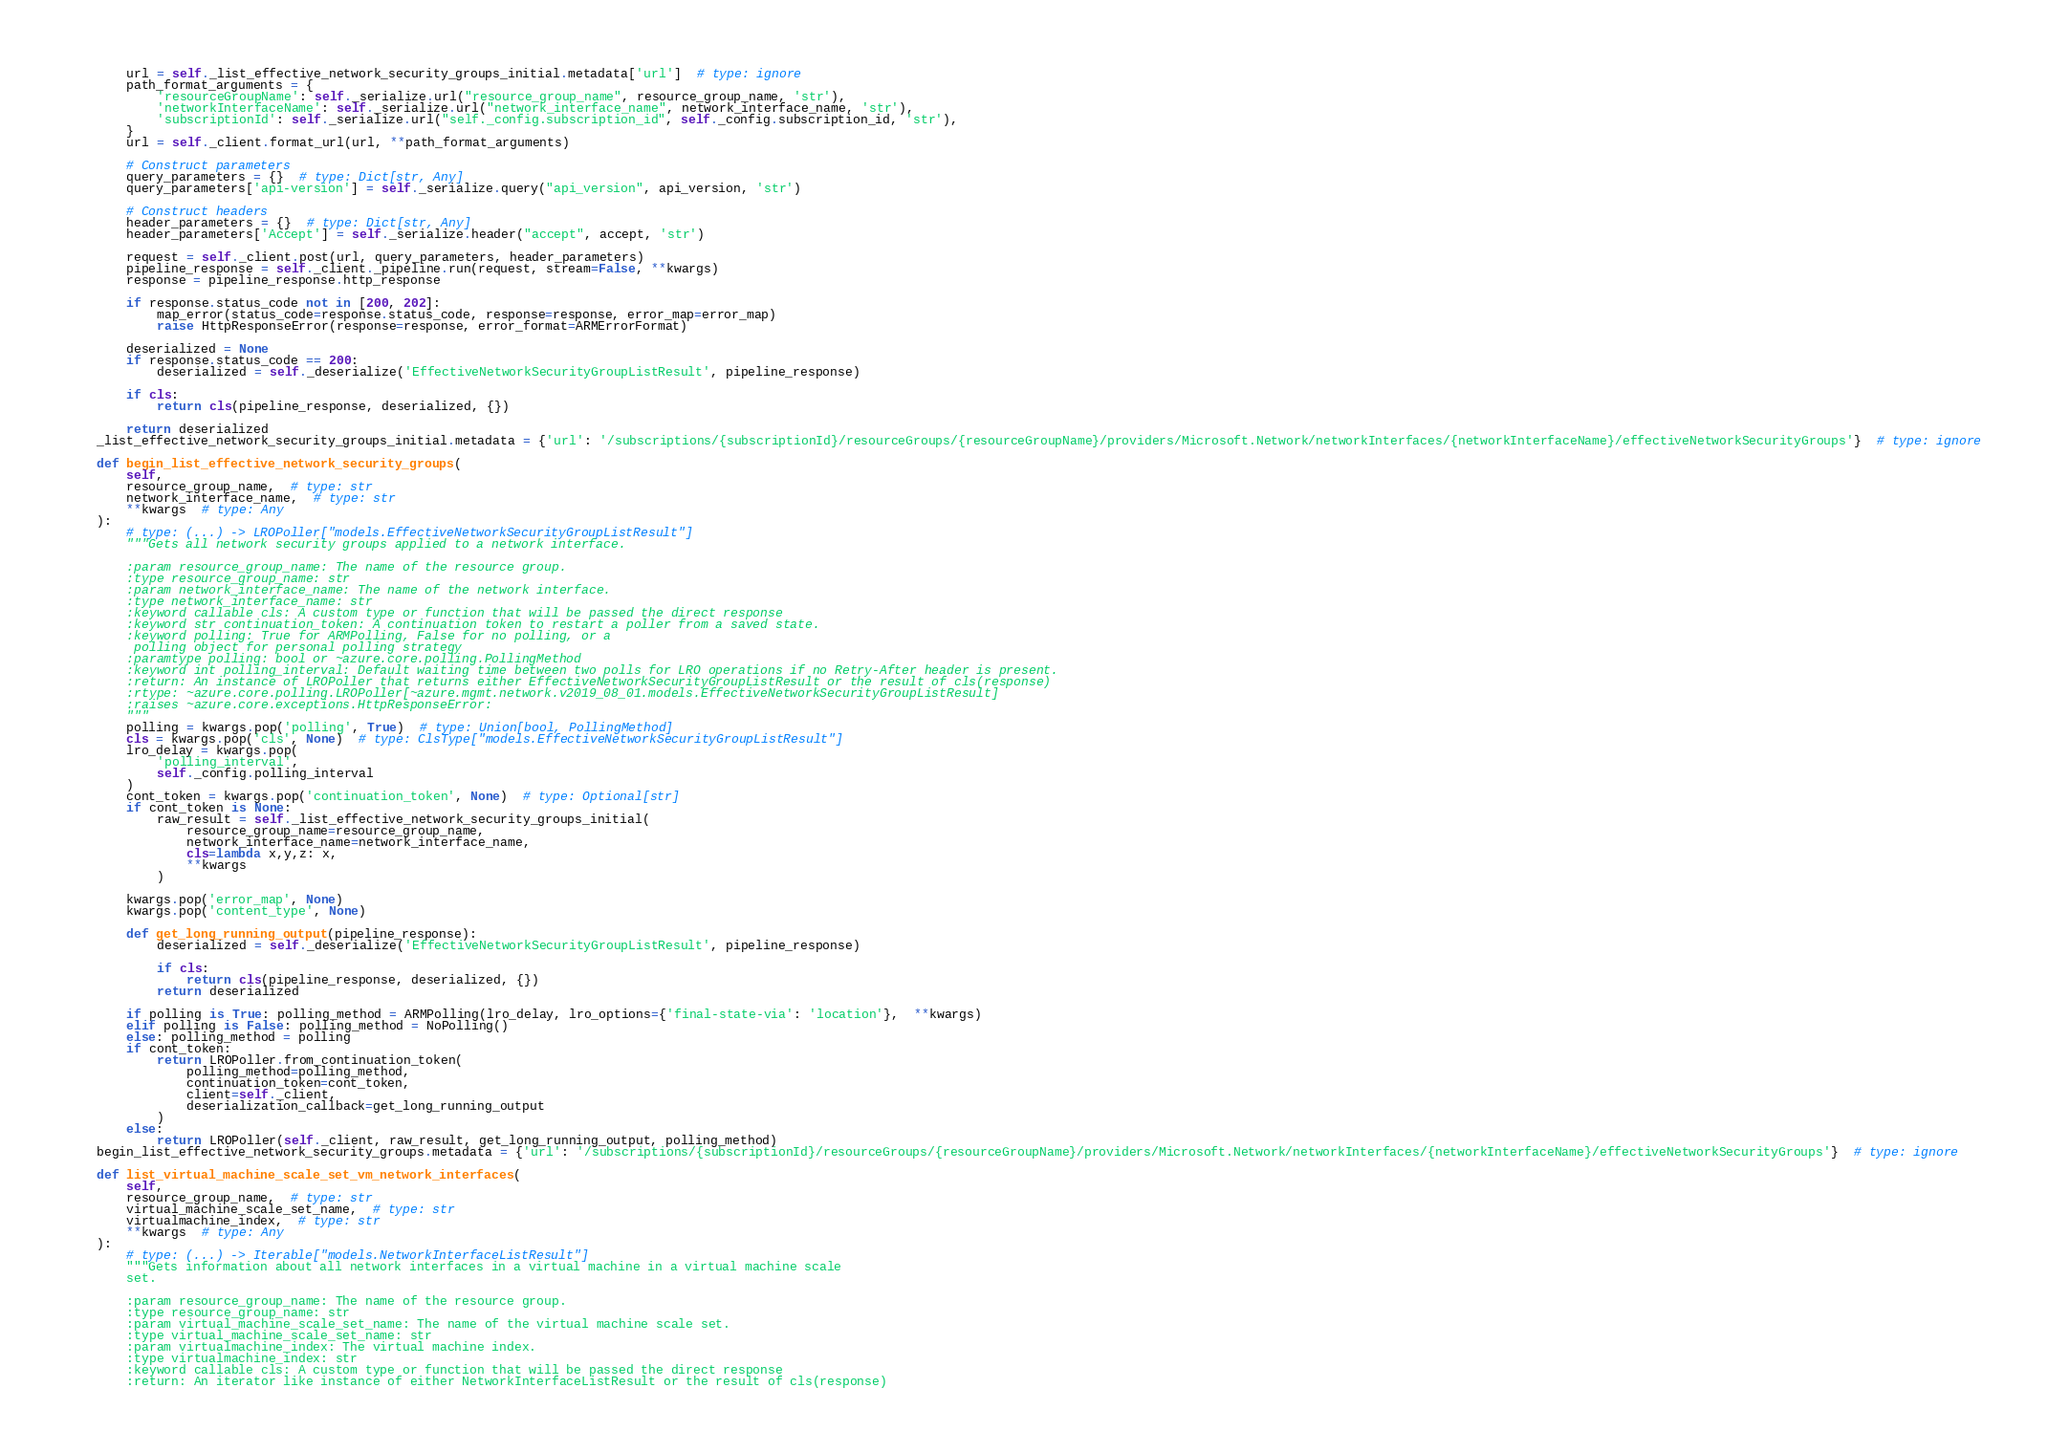Convert code to text. <code><loc_0><loc_0><loc_500><loc_500><_Python_>        url = self._list_effective_network_security_groups_initial.metadata['url']  # type: ignore
        path_format_arguments = {
            'resourceGroupName': self._serialize.url("resource_group_name", resource_group_name, 'str'),
            'networkInterfaceName': self._serialize.url("network_interface_name", network_interface_name, 'str'),
            'subscriptionId': self._serialize.url("self._config.subscription_id", self._config.subscription_id, 'str'),
        }
        url = self._client.format_url(url, **path_format_arguments)

        # Construct parameters
        query_parameters = {}  # type: Dict[str, Any]
        query_parameters['api-version'] = self._serialize.query("api_version", api_version, 'str')

        # Construct headers
        header_parameters = {}  # type: Dict[str, Any]
        header_parameters['Accept'] = self._serialize.header("accept", accept, 'str')

        request = self._client.post(url, query_parameters, header_parameters)
        pipeline_response = self._client._pipeline.run(request, stream=False, **kwargs)
        response = pipeline_response.http_response

        if response.status_code not in [200, 202]:
            map_error(status_code=response.status_code, response=response, error_map=error_map)
            raise HttpResponseError(response=response, error_format=ARMErrorFormat)

        deserialized = None
        if response.status_code == 200:
            deserialized = self._deserialize('EffectiveNetworkSecurityGroupListResult', pipeline_response)

        if cls:
            return cls(pipeline_response, deserialized, {})

        return deserialized
    _list_effective_network_security_groups_initial.metadata = {'url': '/subscriptions/{subscriptionId}/resourceGroups/{resourceGroupName}/providers/Microsoft.Network/networkInterfaces/{networkInterfaceName}/effectiveNetworkSecurityGroups'}  # type: ignore

    def begin_list_effective_network_security_groups(
        self,
        resource_group_name,  # type: str
        network_interface_name,  # type: str
        **kwargs  # type: Any
    ):
        # type: (...) -> LROPoller["models.EffectiveNetworkSecurityGroupListResult"]
        """Gets all network security groups applied to a network interface.

        :param resource_group_name: The name of the resource group.
        :type resource_group_name: str
        :param network_interface_name: The name of the network interface.
        :type network_interface_name: str
        :keyword callable cls: A custom type or function that will be passed the direct response
        :keyword str continuation_token: A continuation token to restart a poller from a saved state.
        :keyword polling: True for ARMPolling, False for no polling, or a
         polling object for personal polling strategy
        :paramtype polling: bool or ~azure.core.polling.PollingMethod
        :keyword int polling_interval: Default waiting time between two polls for LRO operations if no Retry-After header is present.
        :return: An instance of LROPoller that returns either EffectiveNetworkSecurityGroupListResult or the result of cls(response)
        :rtype: ~azure.core.polling.LROPoller[~azure.mgmt.network.v2019_08_01.models.EffectiveNetworkSecurityGroupListResult]
        :raises ~azure.core.exceptions.HttpResponseError:
        """
        polling = kwargs.pop('polling', True)  # type: Union[bool, PollingMethod]
        cls = kwargs.pop('cls', None)  # type: ClsType["models.EffectiveNetworkSecurityGroupListResult"]
        lro_delay = kwargs.pop(
            'polling_interval',
            self._config.polling_interval
        )
        cont_token = kwargs.pop('continuation_token', None)  # type: Optional[str]
        if cont_token is None:
            raw_result = self._list_effective_network_security_groups_initial(
                resource_group_name=resource_group_name,
                network_interface_name=network_interface_name,
                cls=lambda x,y,z: x,
                **kwargs
            )

        kwargs.pop('error_map', None)
        kwargs.pop('content_type', None)

        def get_long_running_output(pipeline_response):
            deserialized = self._deserialize('EffectiveNetworkSecurityGroupListResult', pipeline_response)

            if cls:
                return cls(pipeline_response, deserialized, {})
            return deserialized

        if polling is True: polling_method = ARMPolling(lro_delay, lro_options={'final-state-via': 'location'},  **kwargs)
        elif polling is False: polling_method = NoPolling()
        else: polling_method = polling
        if cont_token:
            return LROPoller.from_continuation_token(
                polling_method=polling_method,
                continuation_token=cont_token,
                client=self._client,
                deserialization_callback=get_long_running_output
            )
        else:
            return LROPoller(self._client, raw_result, get_long_running_output, polling_method)
    begin_list_effective_network_security_groups.metadata = {'url': '/subscriptions/{subscriptionId}/resourceGroups/{resourceGroupName}/providers/Microsoft.Network/networkInterfaces/{networkInterfaceName}/effectiveNetworkSecurityGroups'}  # type: ignore

    def list_virtual_machine_scale_set_vm_network_interfaces(
        self,
        resource_group_name,  # type: str
        virtual_machine_scale_set_name,  # type: str
        virtualmachine_index,  # type: str
        **kwargs  # type: Any
    ):
        # type: (...) -> Iterable["models.NetworkInterfaceListResult"]
        """Gets information about all network interfaces in a virtual machine in a virtual machine scale
        set.

        :param resource_group_name: The name of the resource group.
        :type resource_group_name: str
        :param virtual_machine_scale_set_name: The name of the virtual machine scale set.
        :type virtual_machine_scale_set_name: str
        :param virtualmachine_index: The virtual machine index.
        :type virtualmachine_index: str
        :keyword callable cls: A custom type or function that will be passed the direct response
        :return: An iterator like instance of either NetworkInterfaceListResult or the result of cls(response)</code> 